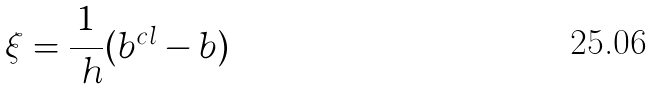Convert formula to latex. <formula><loc_0><loc_0><loc_500><loc_500>\xi = \frac { 1 } { \ h } ( b ^ { c l } - b )</formula> 